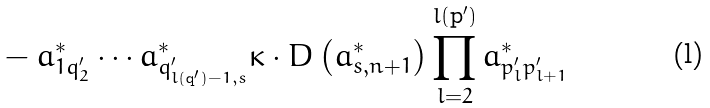<formula> <loc_0><loc_0><loc_500><loc_500>& - a _ { 1 q _ { 2 } ^ { \prime } } ^ { * } \cdots a _ { q _ { l ( \mathbf q ^ { \prime } ) - 1 , s } ^ { \prime } } ^ { * } \kappa \cdot D \left ( a _ { s , n + 1 } ^ { * } \right ) \prod _ { l = 2 } ^ { l ( \mathbf p ^ { \prime } ) } a _ { p _ { l } ^ { \prime } p _ { l + 1 } ^ { \prime } } ^ { * }</formula> 